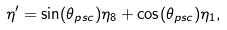Convert formula to latex. <formula><loc_0><loc_0><loc_500><loc_500>\eta ^ { \prime } = \sin ( \theta _ { p s c } ) \eta _ { 8 } + \cos ( \theta _ { p s c } ) \eta _ { 1 } ,</formula> 